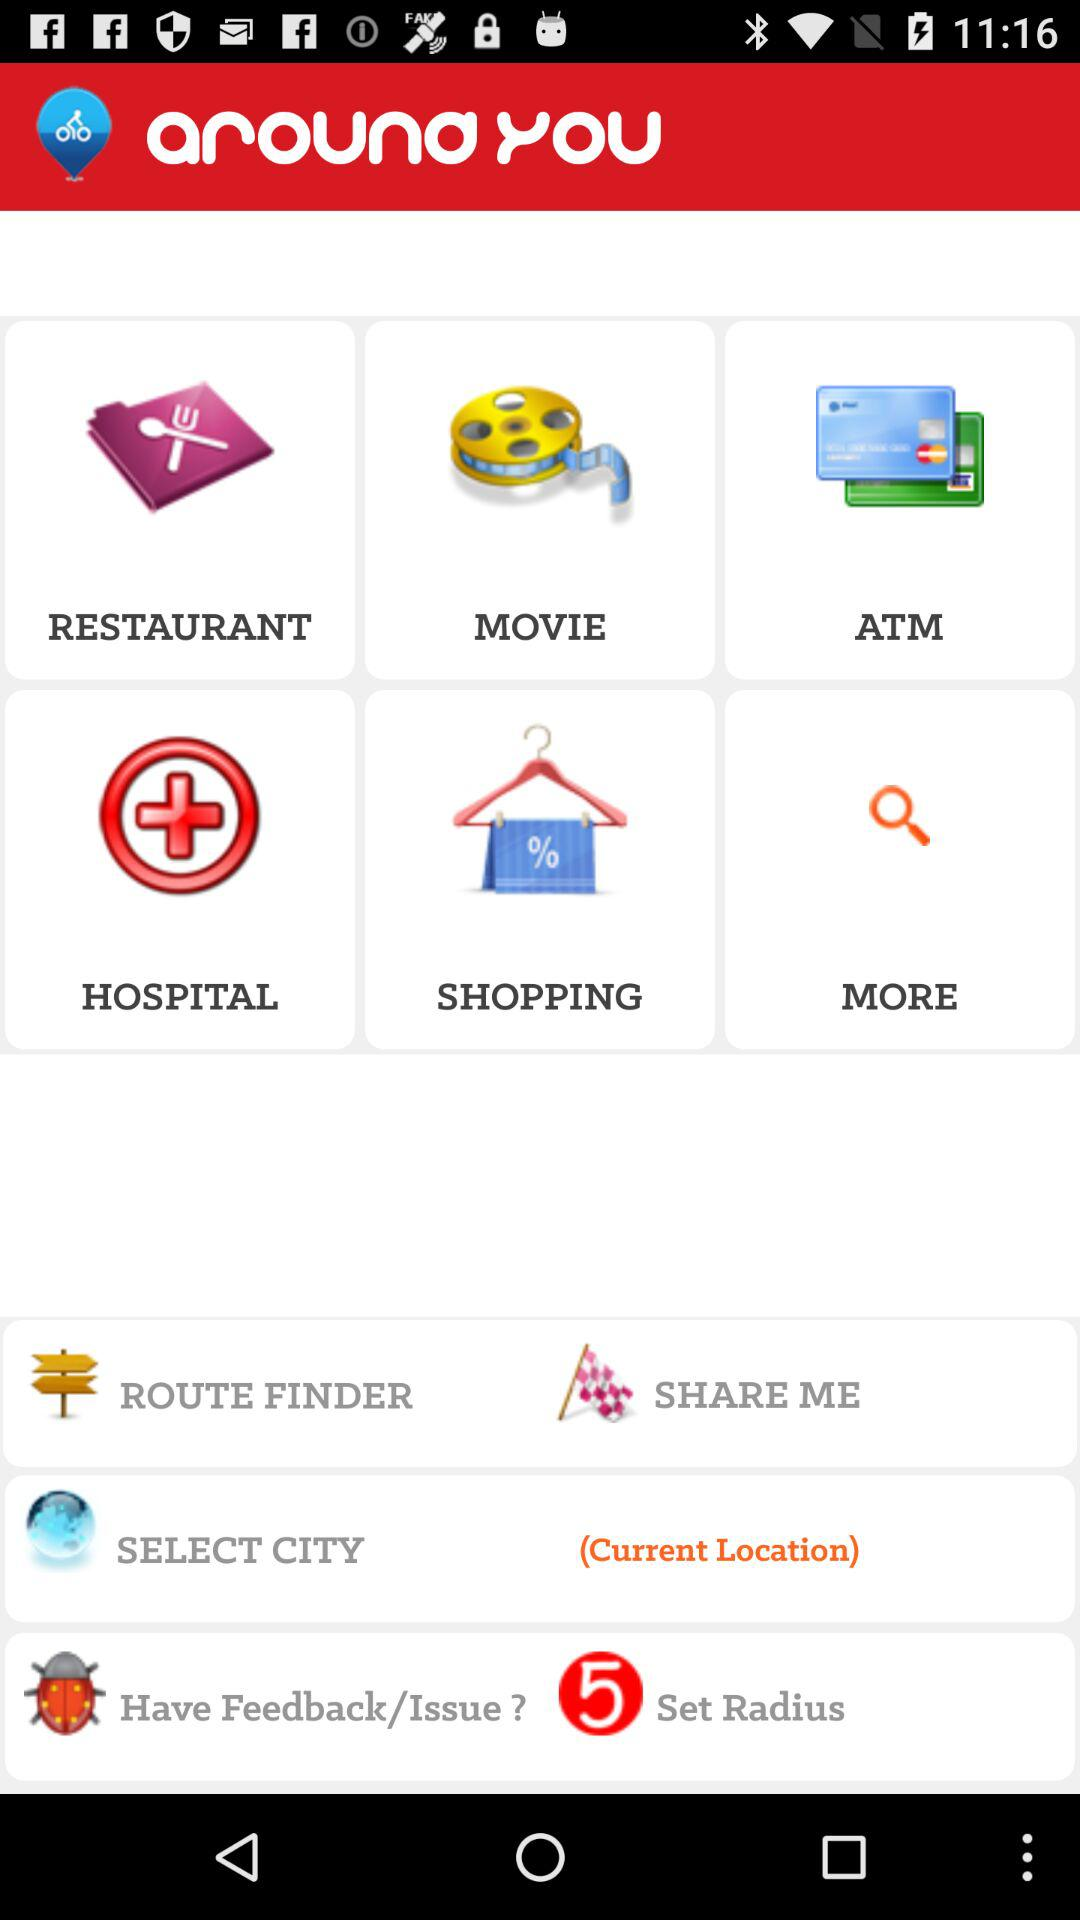What are the available options? The available options are "RESTAURANT", "MOVIE", "ATM", "HOSPITAL", "SHOPPING" and "MORE". 